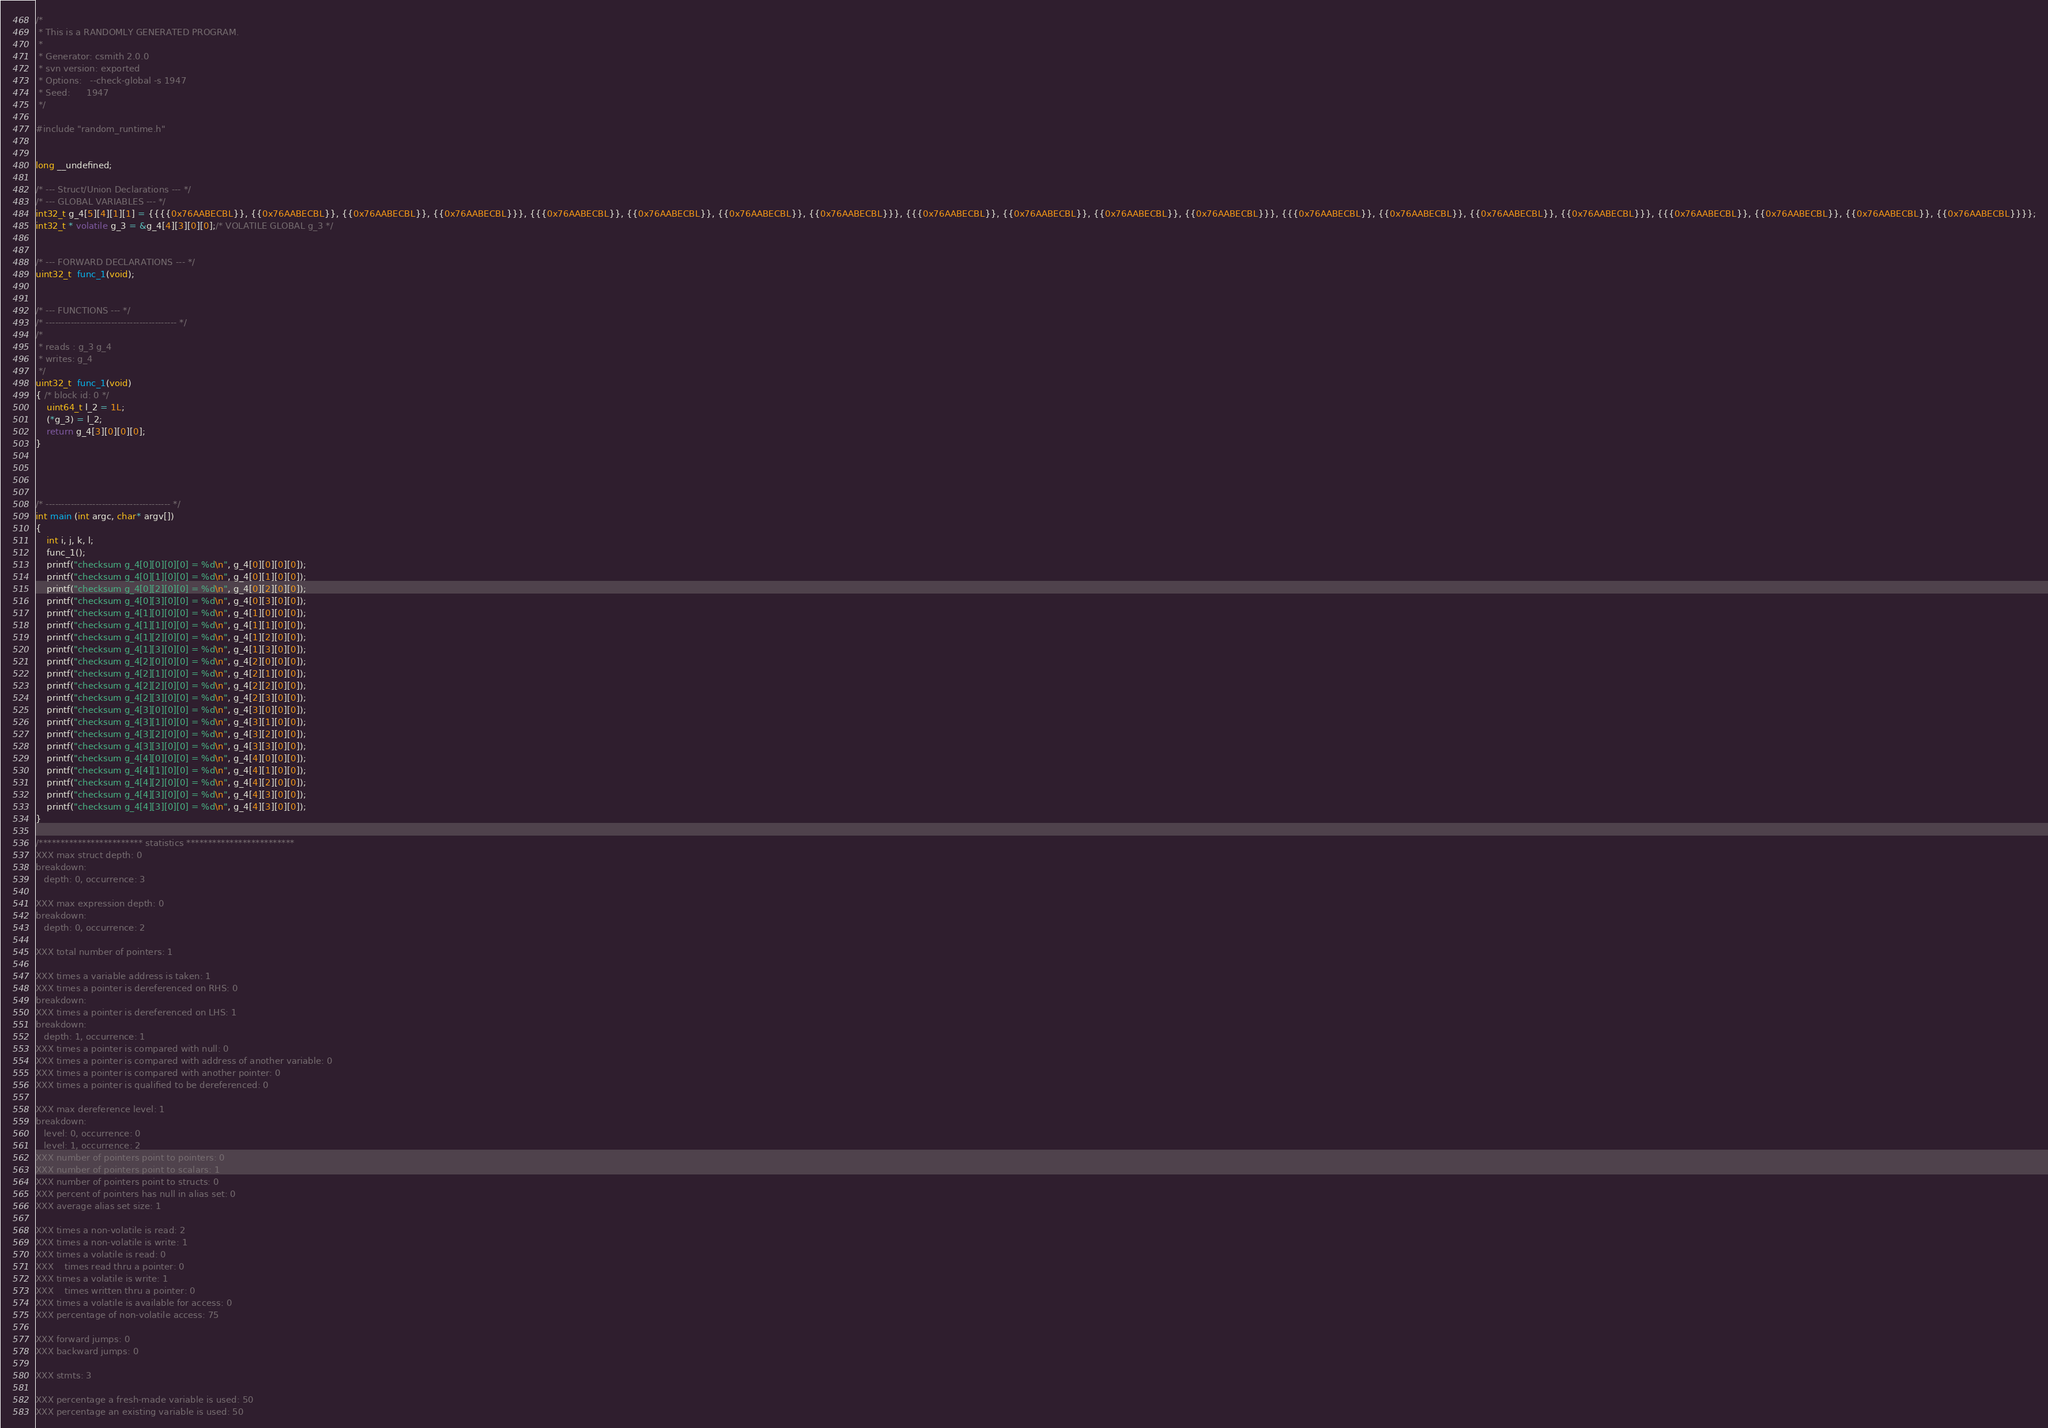<code> <loc_0><loc_0><loc_500><loc_500><_C_>/*
 * This is a RANDOMLY GENERATED PROGRAM.
 *
 * Generator: csmith 2.0.0
 * svn version: exported
 * Options:   --check-global -s 1947
 * Seed:      1947
 */

#include "random_runtime.h"


long __undefined;

/* --- Struct/Union Declarations --- */
/* --- GLOBAL VARIABLES --- */
int32_t g_4[5][4][1][1] = {{{{0x76AABECBL}}, {{0x76AABECBL}}, {{0x76AABECBL}}, {{0x76AABECBL}}}, {{{0x76AABECBL}}, {{0x76AABECBL}}, {{0x76AABECBL}}, {{0x76AABECBL}}}, {{{0x76AABECBL}}, {{0x76AABECBL}}, {{0x76AABECBL}}, {{0x76AABECBL}}}, {{{0x76AABECBL}}, {{0x76AABECBL}}, {{0x76AABECBL}}, {{0x76AABECBL}}}, {{{0x76AABECBL}}, {{0x76AABECBL}}, {{0x76AABECBL}}, {{0x76AABECBL}}}};
int32_t * volatile g_3 = &g_4[4][3][0][0];/* VOLATILE GLOBAL g_3 */


/* --- FORWARD DECLARATIONS --- */
uint32_t  func_1(void);


/* --- FUNCTIONS --- */
/* ------------------------------------------ */
/* 
 * reads : g_3 g_4
 * writes: g_4
 */
uint32_t  func_1(void)
{ /* block id: 0 */
    uint64_t l_2 = 1L;
    (*g_3) = l_2;
    return g_4[3][0][0][0];
}




/* ---------------------------------------- */
int main (int argc, char* argv[])
{
    int i, j, k, l;
    func_1();
    printf("checksum g_4[0][0][0][0] = %d\n", g_4[0][0][0][0]);
    printf("checksum g_4[0][1][0][0] = %d\n", g_4[0][1][0][0]);
    printf("checksum g_4[0][2][0][0] = %d\n", g_4[0][2][0][0]);
    printf("checksum g_4[0][3][0][0] = %d\n", g_4[0][3][0][0]);
    printf("checksum g_4[1][0][0][0] = %d\n", g_4[1][0][0][0]);
    printf("checksum g_4[1][1][0][0] = %d\n", g_4[1][1][0][0]);
    printf("checksum g_4[1][2][0][0] = %d\n", g_4[1][2][0][0]);
    printf("checksum g_4[1][3][0][0] = %d\n", g_4[1][3][0][0]);
    printf("checksum g_4[2][0][0][0] = %d\n", g_4[2][0][0][0]);
    printf("checksum g_4[2][1][0][0] = %d\n", g_4[2][1][0][0]);
    printf("checksum g_4[2][2][0][0] = %d\n", g_4[2][2][0][0]);
    printf("checksum g_4[2][3][0][0] = %d\n", g_4[2][3][0][0]);
    printf("checksum g_4[3][0][0][0] = %d\n", g_4[3][0][0][0]);
    printf("checksum g_4[3][1][0][0] = %d\n", g_4[3][1][0][0]);
    printf("checksum g_4[3][2][0][0] = %d\n", g_4[3][2][0][0]);
    printf("checksum g_4[3][3][0][0] = %d\n", g_4[3][3][0][0]);
    printf("checksum g_4[4][0][0][0] = %d\n", g_4[4][0][0][0]);
    printf("checksum g_4[4][1][0][0] = %d\n", g_4[4][1][0][0]);
    printf("checksum g_4[4][2][0][0] = %d\n", g_4[4][2][0][0]);
    printf("checksum g_4[4][3][0][0] = %d\n", g_4[4][3][0][0]);
    printf("checksum g_4[4][3][0][0] = %d\n", g_4[4][3][0][0]);
}

/************************ statistics *************************
XXX max struct depth: 0
breakdown:
   depth: 0, occurrence: 3

XXX max expression depth: 0
breakdown:
   depth: 0, occurrence: 2

XXX total number of pointers: 1

XXX times a variable address is taken: 1
XXX times a pointer is dereferenced on RHS: 0
breakdown:
XXX times a pointer is dereferenced on LHS: 1
breakdown:
   depth: 1, occurrence: 1
XXX times a pointer is compared with null: 0
XXX times a pointer is compared with address of another variable: 0
XXX times a pointer is compared with another pointer: 0
XXX times a pointer is qualified to be dereferenced: 0

XXX max dereference level: 1
breakdown:
   level: 0, occurrence: 0
   level: 1, occurrence: 2
XXX number of pointers point to pointers: 0
XXX number of pointers point to scalars: 1
XXX number of pointers point to structs: 0
XXX percent of pointers has null in alias set: 0
XXX average alias set size: 1

XXX times a non-volatile is read: 2
XXX times a non-volatile is write: 1
XXX times a volatile is read: 0
XXX    times read thru a pointer: 0
XXX times a volatile is write: 1
XXX    times written thru a pointer: 0
XXX times a volatile is available for access: 0
XXX percentage of non-volatile access: 75

XXX forward jumps: 0
XXX backward jumps: 0

XXX stmts: 3

XXX percentage a fresh-made variable is used: 50
XXX percentage an existing variable is used: 50</code> 